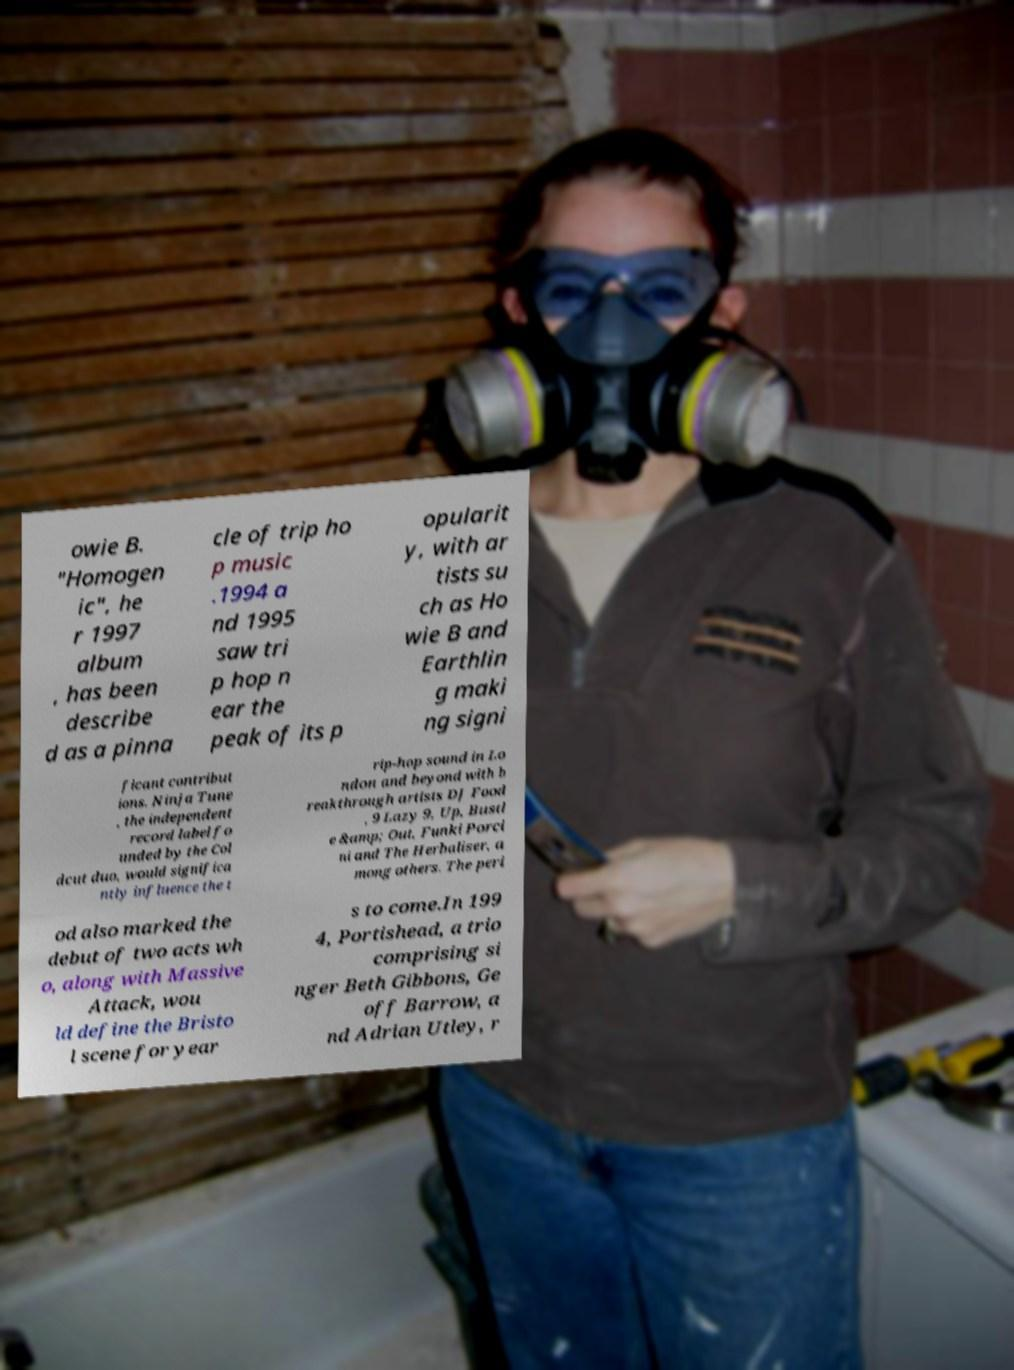I need the written content from this picture converted into text. Can you do that? owie B. "Homogen ic", he r 1997 album , has been describe d as a pinna cle of trip ho p music .1994 a nd 1995 saw tri p hop n ear the peak of its p opularit y, with ar tists su ch as Ho wie B and Earthlin g maki ng signi ficant contribut ions. Ninja Tune , the independent record label fo unded by the Col dcut duo, would significa ntly influence the t rip-hop sound in Lo ndon and beyond with b reakthrough artists DJ Food , 9 Lazy 9, Up, Bustl e &amp; Out, Funki Porci ni and The Herbaliser, a mong others. The peri od also marked the debut of two acts wh o, along with Massive Attack, wou ld define the Bristo l scene for year s to come.In 199 4, Portishead, a trio comprising si nger Beth Gibbons, Ge off Barrow, a nd Adrian Utley, r 